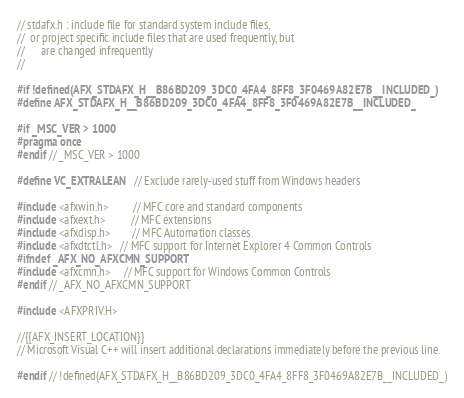Convert code to text. <code><loc_0><loc_0><loc_500><loc_500><_C_>// stdafx.h : include file for standard system include files,
//  or project specific include files that are used frequently, but
//      are changed infrequently
//

#if !defined(AFX_STDAFX_H__B86BD209_3DC0_4FA4_8FF8_3F0469A82E7B__INCLUDED_)
#define AFX_STDAFX_H__B86BD209_3DC0_4FA4_8FF8_3F0469A82E7B__INCLUDED_

#if _MSC_VER > 1000
#pragma once
#endif // _MSC_VER > 1000

#define VC_EXTRALEAN    // Exclude rarely-used stuff from Windows headers

#include <afxwin.h>         // MFC core and standard components
#include <afxext.h>         // MFC extensions
#include <afxdisp.h>        // MFC Automation classes
#include <afxdtctl.h>   // MFC support for Internet Explorer 4 Common Controls
#ifndef _AFX_NO_AFXCMN_SUPPORT
#include <afxcmn.h>     // MFC support for Windows Common Controls
#endif // _AFX_NO_AFXCMN_SUPPORT

#include <AFXPRIV.H>

//{{AFX_INSERT_LOCATION}}
// Microsoft Visual C++ will insert additional declarations immediately before the previous line.

#endif // !defined(AFX_STDAFX_H__B86BD209_3DC0_4FA4_8FF8_3F0469A82E7B__INCLUDED_)
</code> 